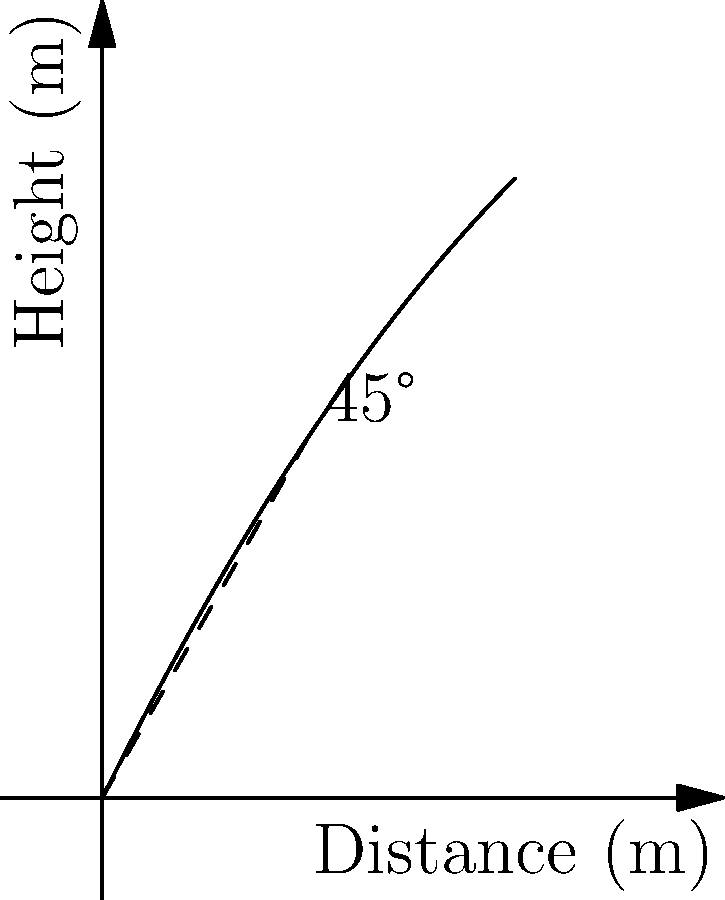During a power outage, you decide to practice throwing objects in your backyard. You want to determine the optimal angle to throw a stone for maximum distance. Assuming air resistance is negligible, at what angle should you throw the stone to achieve the farthest distance? To find the optimal angle for maximum distance when throwing an object, we can follow these steps:

1. Recall that the trajectory of a projectile without air resistance follows a parabolic path.

2. The range (R) of a projectile is given by the equation:
   $$R = \frac{v_0^2 \sin(2\theta)}{g}$$
   where $v_0$ is the initial velocity, $\theta$ is the launch angle, and $g$ is the acceleration due to gravity.

3. To maximize the range, we need to maximize $\sin(2\theta)$.

4. The maximum value of sine function is 1, which occurs when its argument is 90°.

5. Therefore, we want:
   $$2\theta = 90°$$

6. Solving for $\theta$:
   $$\theta = 45°$$

7. This result is independent of the initial velocity and the acceleration due to gravity, making it universally applicable for all throws neglecting air resistance.
Answer: 45° 